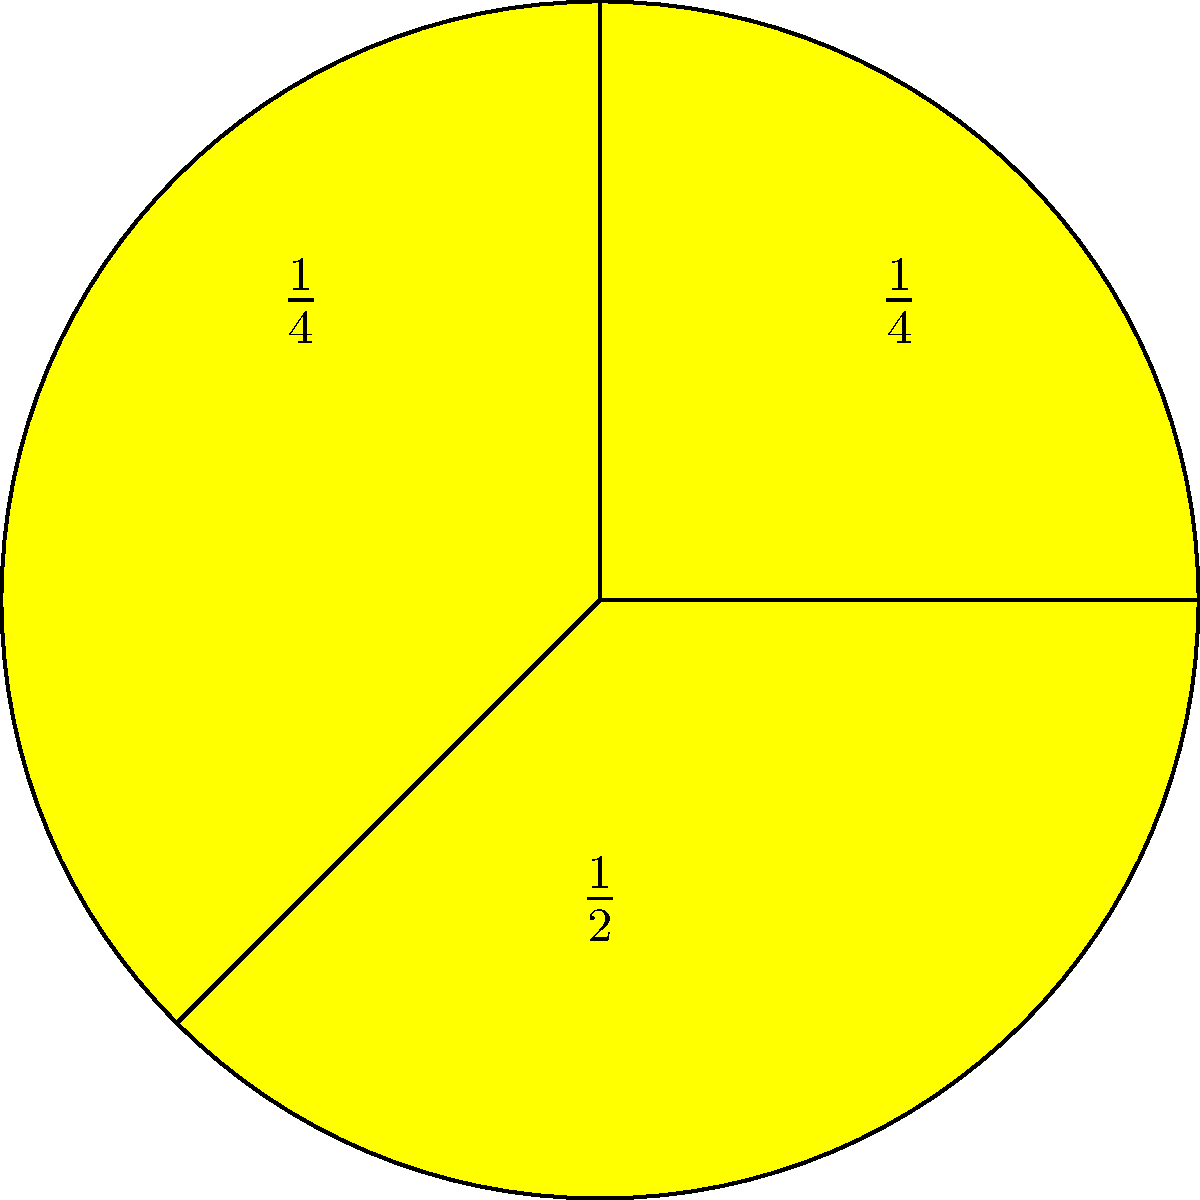Your child is learning about fractions and asks you to explain how much of the pizza is left if they eat one-quarter of it. Using the pizza chart above, how would you explain the remaining fraction of the pizza? Let's break this down step-by-step:

1. First, we need to understand what the pizza chart shows:
   - The whole pizza is divided into four equal parts.
   - Each part represents $\frac{1}{4}$ (one-quarter) of the pizza.

2. Your child has eaten one-quarter ($\frac{1}{4}$) of the pizza.

3. To find out how much is left, we need to subtract the eaten part from the whole:
   - The whole pizza is represented by 1 or $\frac{4}{4}$.
   - We subtract the eaten part: $\frac{4}{4} - \frac{1}{4}$

4. To perform this subtraction:
   $\frac{4}{4} - \frac{1}{4} = \frac{3}{4}$

5. We can verify this visually:
   - If we cover one slice of the pizza, we can see that three slices remain.
   - These three slices together make up $\frac{3}{4}$ of the pizza.

Therefore, after eating one-quarter of the pizza, three-quarters ($\frac{3}{4}$) of the pizza remain.
Answer: $\frac{3}{4}$ of the pizza remains 